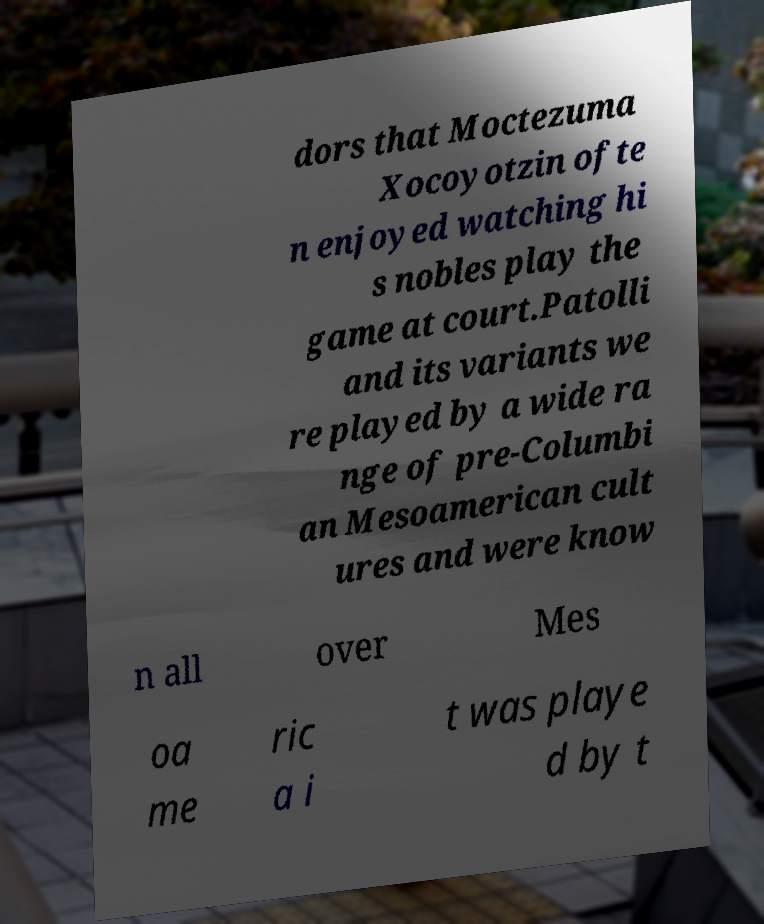Please read and relay the text visible in this image. What does it say? dors that Moctezuma Xocoyotzin ofte n enjoyed watching hi s nobles play the game at court.Patolli and its variants we re played by a wide ra nge of pre-Columbi an Mesoamerican cult ures and were know n all over Mes oa me ric a i t was playe d by t 